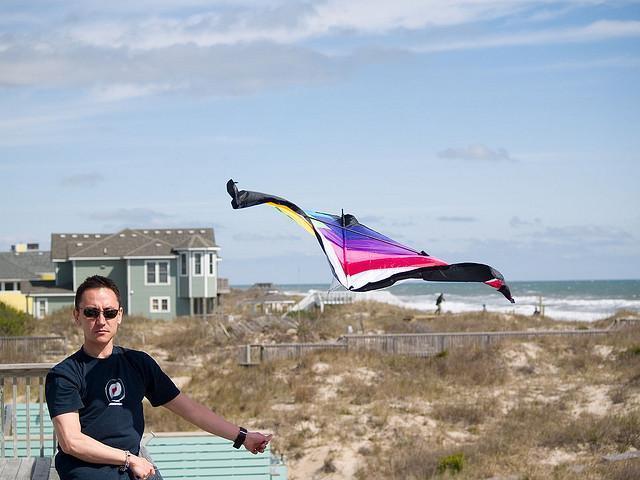How many people are in the photo?
Give a very brief answer. 1. 